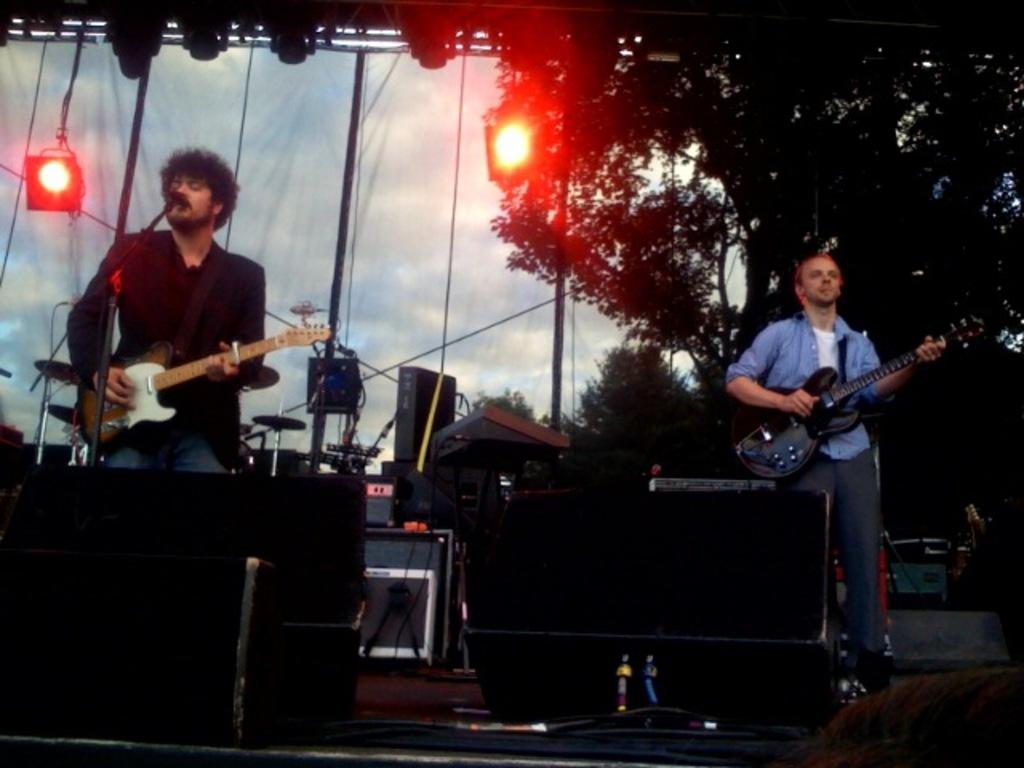How many people are in the image? There are two men in the image. What are the men holding in the image? Both men are holding guitars. Can you describe the position of one of the men? One man is in front of a microphone. What can be seen in the background of the image? There is equipment, lights, and trees visible in the background. What type of gun is the man holding in the image? There is no gun present in the image; both men are holding guitars. How does the man stretch his nose in the image? There is no mention of the man stretching his nose in the image, as the focus is on the men holding guitars and standing near a microphone. 